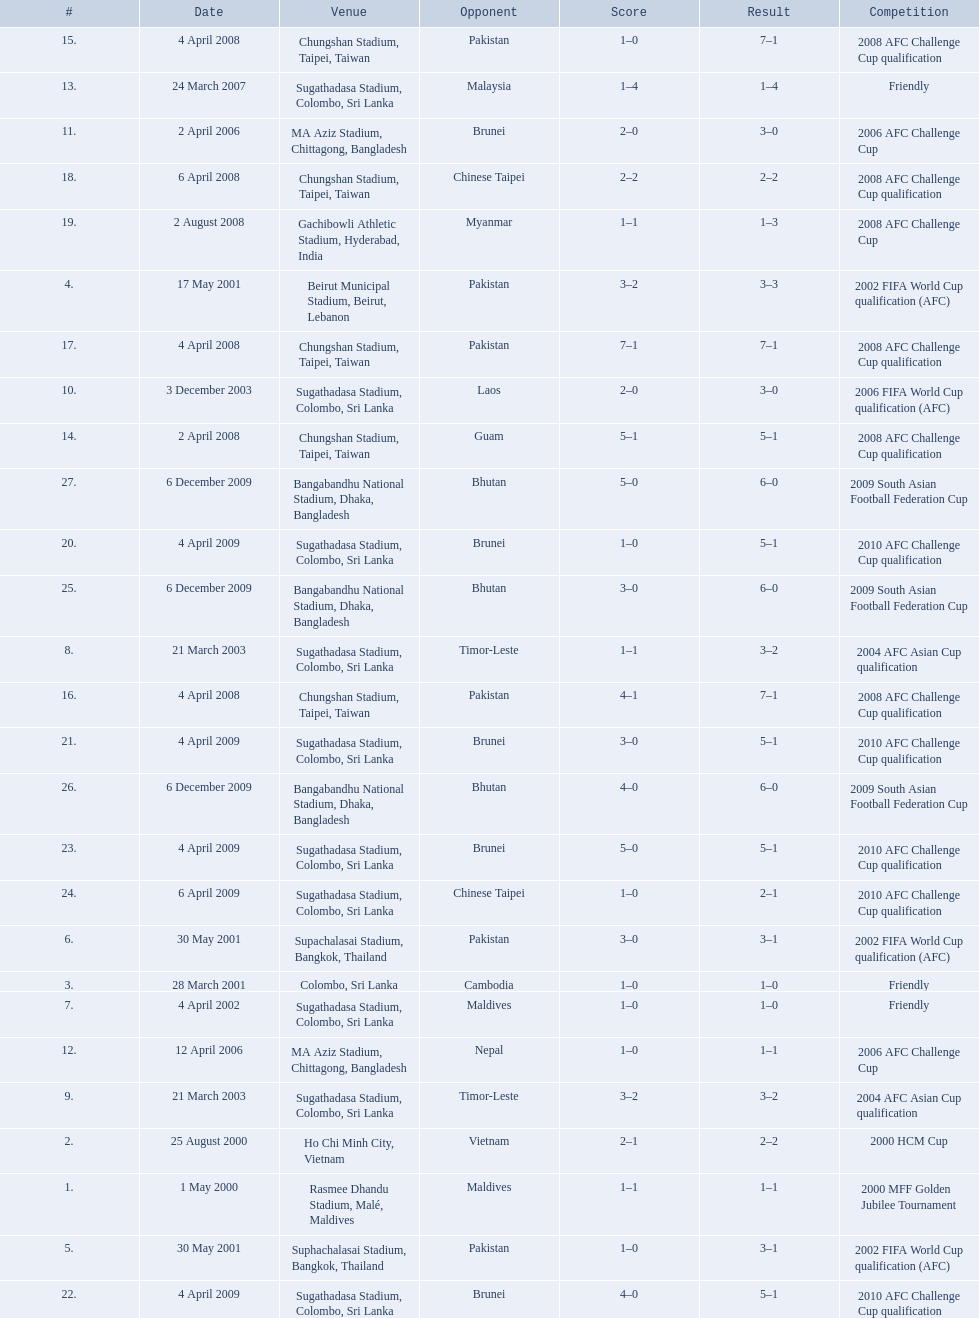What are the venues Rasmee Dhandu Stadium, Malé, Maldives, Ho Chi Minh City, Vietnam, Colombo, Sri Lanka, Beirut Municipal Stadium, Beirut, Lebanon, Suphachalasai Stadium, Bangkok, Thailand, Supachalasai Stadium, Bangkok, Thailand, Sugathadasa Stadium, Colombo, Sri Lanka, Sugathadasa Stadium, Colombo, Sri Lanka, Sugathadasa Stadium, Colombo, Sri Lanka, Sugathadasa Stadium, Colombo, Sri Lanka, MA Aziz Stadium, Chittagong, Bangladesh, MA Aziz Stadium, Chittagong, Bangladesh, Sugathadasa Stadium, Colombo, Sri Lanka, Chungshan Stadium, Taipei, Taiwan, Chungshan Stadium, Taipei, Taiwan, Chungshan Stadium, Taipei, Taiwan, Chungshan Stadium, Taipei, Taiwan, Chungshan Stadium, Taipei, Taiwan, Gachibowli Athletic Stadium, Hyderabad, India, Sugathadasa Stadium, Colombo, Sri Lanka, Sugathadasa Stadium, Colombo, Sri Lanka, Sugathadasa Stadium, Colombo, Sri Lanka, Sugathadasa Stadium, Colombo, Sri Lanka, Sugathadasa Stadium, Colombo, Sri Lanka, Bangabandhu National Stadium, Dhaka, Bangladesh, Bangabandhu National Stadium, Dhaka, Bangladesh, Bangabandhu National Stadium, Dhaka, Bangladesh. What are the #'s? 1., 2., 3., 4., 5., 6., 7., 8., 9., 10., 11., 12., 13., 14., 15., 16., 17., 18., 19., 20., 21., 22., 23., 24., 25., 26., 27. Which one is #1? Rasmee Dhandu Stadium, Malé, Maldives. Parse the table in full. {'header': ['#', 'Date', 'Venue', 'Opponent', 'Score', 'Result', 'Competition'], 'rows': [['15.', '4 April 2008', 'Chungshan Stadium, Taipei, Taiwan', 'Pakistan', '1–0', '7–1', '2008 AFC Challenge Cup qualification'], ['13.', '24 March 2007', 'Sugathadasa Stadium, Colombo, Sri Lanka', 'Malaysia', '1–4', '1–4', 'Friendly'], ['11.', '2 April 2006', 'MA Aziz Stadium, Chittagong, Bangladesh', 'Brunei', '2–0', '3–0', '2006 AFC Challenge Cup'], ['18.', '6 April 2008', 'Chungshan Stadium, Taipei, Taiwan', 'Chinese Taipei', '2–2', '2–2', '2008 AFC Challenge Cup qualification'], ['19.', '2 August 2008', 'Gachibowli Athletic Stadium, Hyderabad, India', 'Myanmar', '1–1', '1–3', '2008 AFC Challenge Cup'], ['4.', '17 May 2001', 'Beirut Municipal Stadium, Beirut, Lebanon', 'Pakistan', '3–2', '3–3', '2002 FIFA World Cup qualification (AFC)'], ['17.', '4 April 2008', 'Chungshan Stadium, Taipei, Taiwan', 'Pakistan', '7–1', '7–1', '2008 AFC Challenge Cup qualification'], ['10.', '3 December 2003', 'Sugathadasa Stadium, Colombo, Sri Lanka', 'Laos', '2–0', '3–0', '2006 FIFA World Cup qualification (AFC)'], ['14.', '2 April 2008', 'Chungshan Stadium, Taipei, Taiwan', 'Guam', '5–1', '5–1', '2008 AFC Challenge Cup qualification'], ['27.', '6 December 2009', 'Bangabandhu National Stadium, Dhaka, Bangladesh', 'Bhutan', '5–0', '6–0', '2009 South Asian Football Federation Cup'], ['20.', '4 April 2009', 'Sugathadasa Stadium, Colombo, Sri Lanka', 'Brunei', '1–0', '5–1', '2010 AFC Challenge Cup qualification'], ['25.', '6 December 2009', 'Bangabandhu National Stadium, Dhaka, Bangladesh', 'Bhutan', '3–0', '6–0', '2009 South Asian Football Federation Cup'], ['8.', '21 March 2003', 'Sugathadasa Stadium, Colombo, Sri Lanka', 'Timor-Leste', '1–1', '3–2', '2004 AFC Asian Cup qualification'], ['16.', '4 April 2008', 'Chungshan Stadium, Taipei, Taiwan', 'Pakistan', '4–1', '7–1', '2008 AFC Challenge Cup qualification'], ['21.', '4 April 2009', 'Sugathadasa Stadium, Colombo, Sri Lanka', 'Brunei', '3–0', '5–1', '2010 AFC Challenge Cup qualification'], ['26.', '6 December 2009', 'Bangabandhu National Stadium, Dhaka, Bangladesh', 'Bhutan', '4–0', '6–0', '2009 South Asian Football Federation Cup'], ['23.', '4 April 2009', 'Sugathadasa Stadium, Colombo, Sri Lanka', 'Brunei', '5–0', '5–1', '2010 AFC Challenge Cup qualification'], ['24.', '6 April 2009', 'Sugathadasa Stadium, Colombo, Sri Lanka', 'Chinese Taipei', '1–0', '2–1', '2010 AFC Challenge Cup qualification'], ['6.', '30 May 2001', 'Supachalasai Stadium, Bangkok, Thailand', 'Pakistan', '3–0', '3–1', '2002 FIFA World Cup qualification (AFC)'], ['3.', '28 March 2001', 'Colombo, Sri Lanka', 'Cambodia', '1–0', '1–0', 'Friendly'], ['7.', '4 April 2002', 'Sugathadasa Stadium, Colombo, Sri Lanka', 'Maldives', '1–0', '1–0', 'Friendly'], ['12.', '12 April 2006', 'MA Aziz Stadium, Chittagong, Bangladesh', 'Nepal', '1–0', '1–1', '2006 AFC Challenge Cup'], ['9.', '21 March 2003', 'Sugathadasa Stadium, Colombo, Sri Lanka', 'Timor-Leste', '3–2', '3–2', '2004 AFC Asian Cup qualification'], ['2.', '25 August 2000', 'Ho Chi Minh City, Vietnam', 'Vietnam', '2–1', '2–2', '2000 HCM Cup'], ['1.', '1 May 2000', 'Rasmee Dhandu Stadium, Malé, Maldives', 'Maldives', '1–1', '1–1', '2000 MFF Golden Jubilee Tournament'], ['5.', '30 May 2001', 'Suphachalasai Stadium, Bangkok, Thailand', 'Pakistan', '1–0', '3–1', '2002 FIFA World Cup qualification (AFC)'], ['22.', '4 April 2009', 'Sugathadasa Stadium, Colombo, Sri Lanka', 'Brunei', '4–0', '5–1', '2010 AFC Challenge Cup qualification']]} 